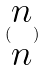<formula> <loc_0><loc_0><loc_500><loc_500>( \begin{matrix} n \\ n \end{matrix} )</formula> 